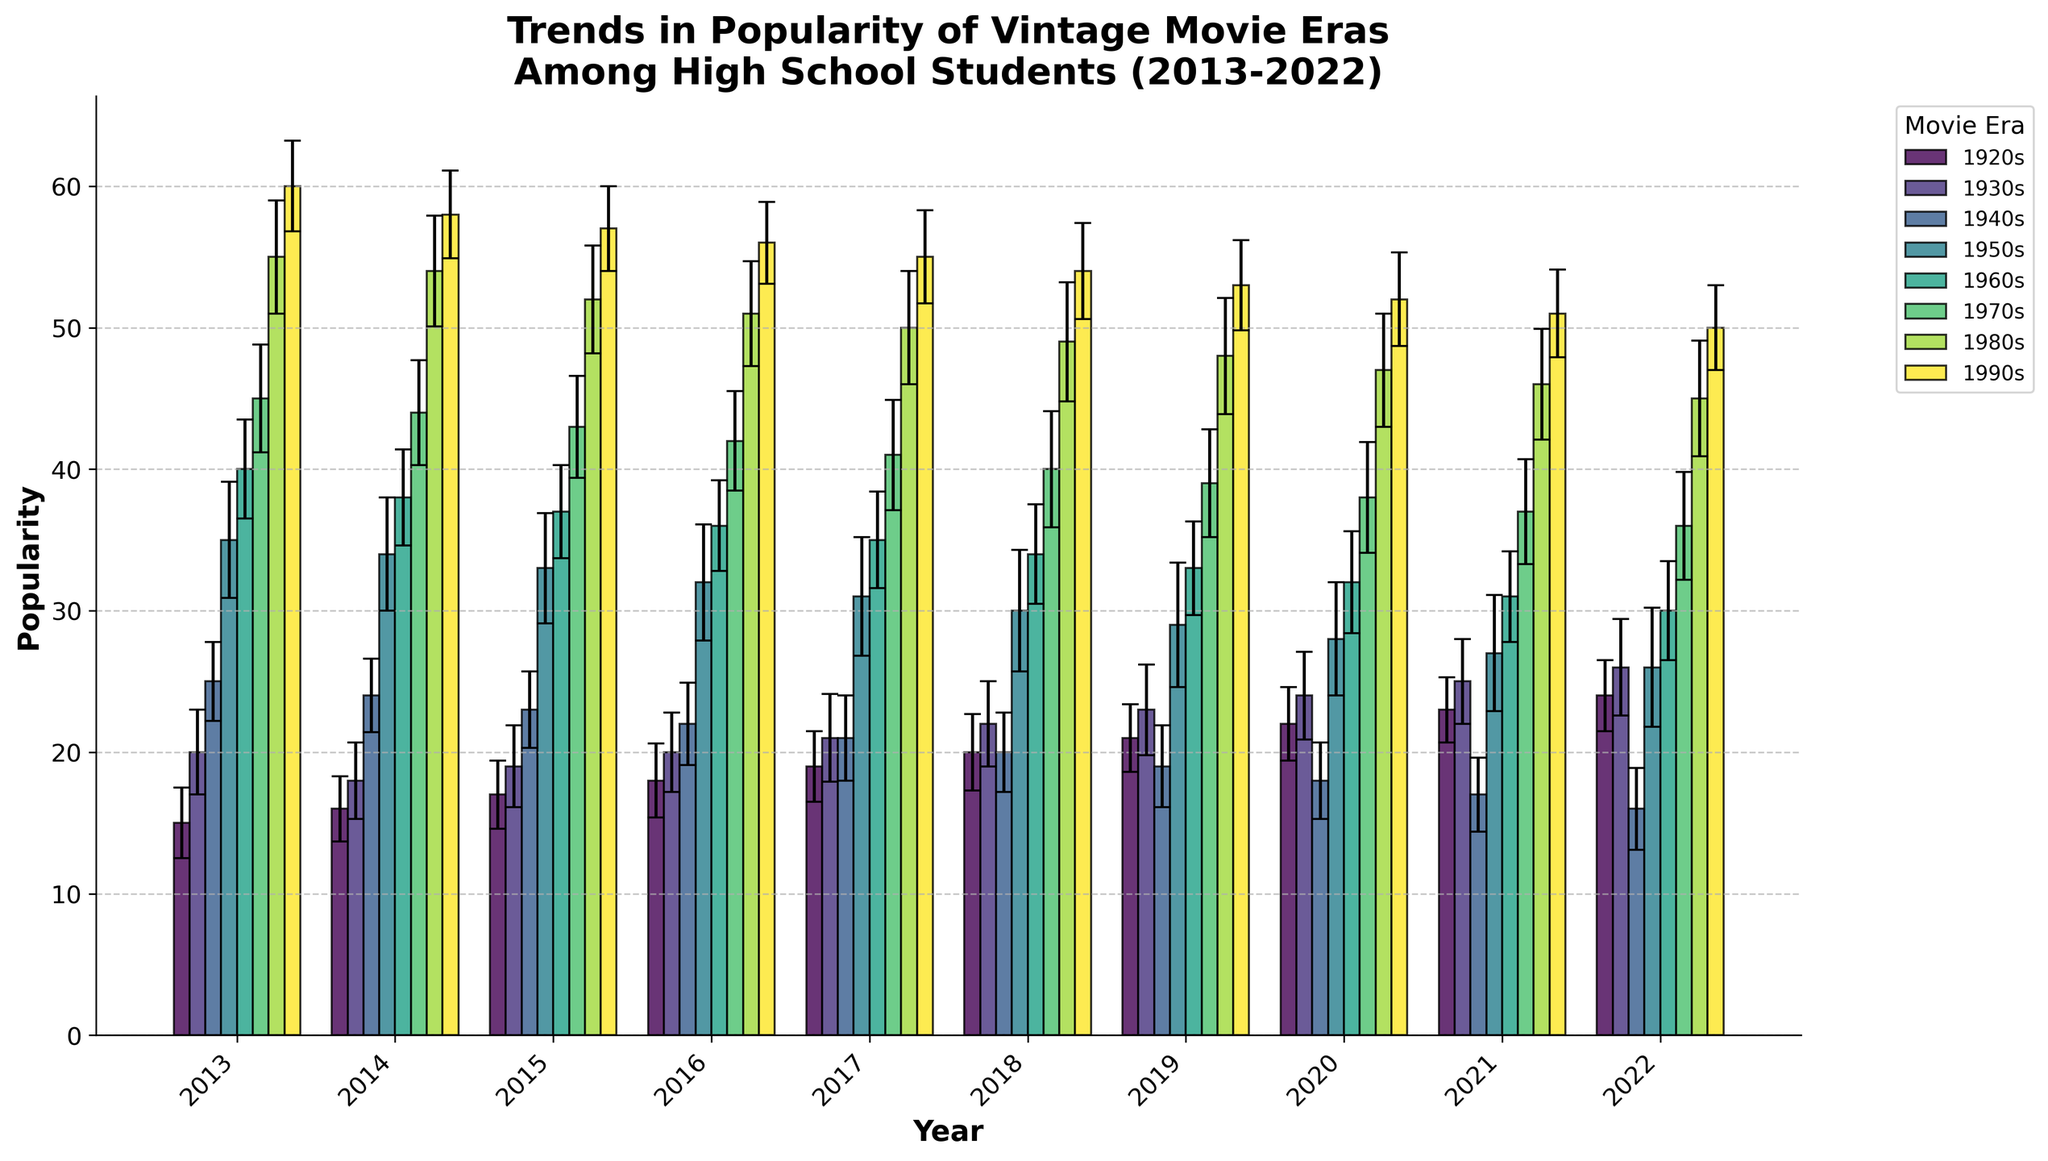What's the title of the figure? The title of the figure is usually displayed at the top of the chart. In this case, it is "Trends in Popularity of Vintage Movie Eras Among High School Students (2013-2022)."
Answer: Trends in Popularity of Vintage Movie Eras Among High School Students (2013-2022) What does the y-axis represent? The y-axis represents the popularity of the vintage movie eras. This is apparent from the y-axis label, which is "Popularity."
Answer: Popularity Which movie era had the highest average popularity in 2013? To determine this, we look at the bars for 2013 and find the highest one. The highest average popularity in 2013 was for the 1990s, with a value of 60.
Answer: 1990s How did the popularity of 1960s movies change from 2013 to 2022? To find out, we compare the heights of the bars for the 1960s era in 2013 and 2022. In 2013, the popularity was 40, and it decreased to 30 by 2022.
Answer: Decreased What's the range of popularity for the 1980s era in 2020 considering the error bars? The popularity for the 1980s era in 2020 is 47, with a standard deviation of ±4. Therefore, the range is 47 - 4 to 47 + 4, which is 43 to 51.
Answer: 43 to 51 Which two eras had similar popularity in 2016? Look for bars that are close to each other in height for the year 2016. The 1930s and 1920s have similar popularities, which are 20 and 18 respectively.
Answer: 1930s and 1920s How does the error bar for 1950s in 2022 compare to the error bar for 1990s in the same year? The error bar represents the standard deviation. For the 1950s in 2022, the standard deviation is 4.2, and for the 1990s, it is 3.0. The error bar for the 1950s is longer.
Answer: Longer Which era shows the most significant decrease in popularity from its highest peak to 2022? First, we need to identify the highest peak for each era and compare it to their corresponding values in 2022. The 1990s had the highest peak with 60 in 2013 and decreased to 50 in 2022, a drop of 10.
Answer: 1990s What is the lowest recorded popularity value for any era in any year? Scan all the bars for the lowest height. The 1940s in 2022 had the lowest popularity, with a value of 16.
Answer: 16 